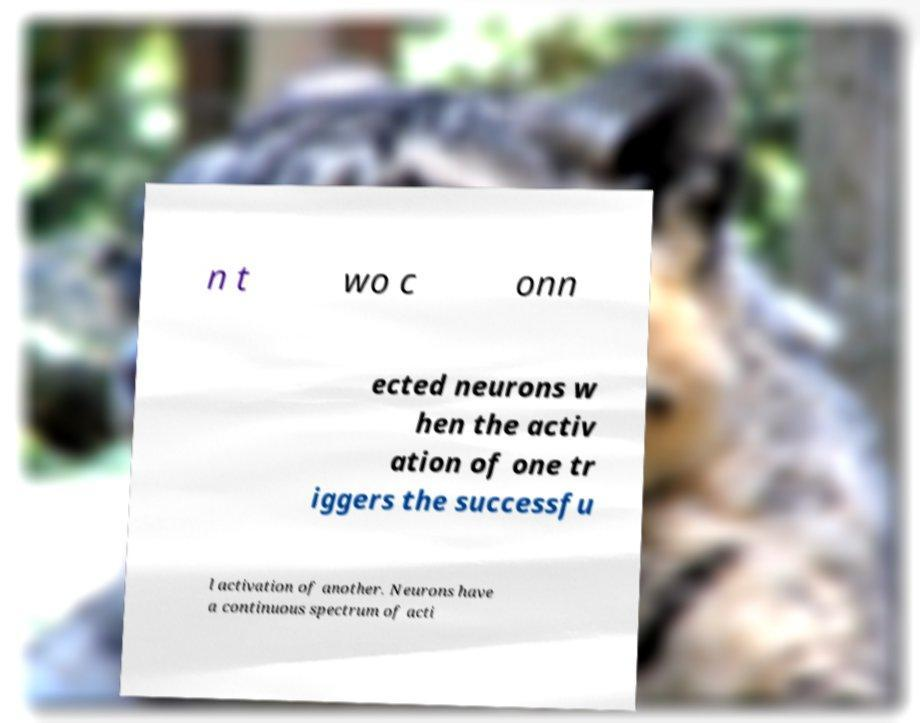Please read and relay the text visible in this image. What does it say? n t wo c onn ected neurons w hen the activ ation of one tr iggers the successfu l activation of another. Neurons have a continuous spectrum of acti 